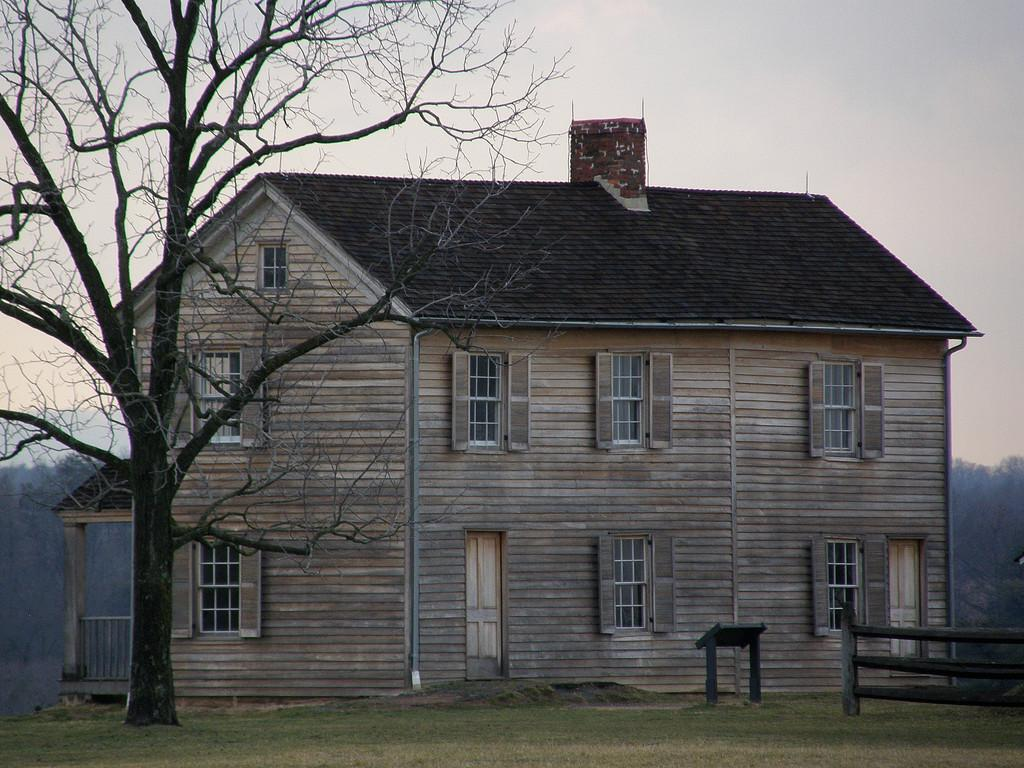What type of plant can be seen in the image? There is a tree in the image. What type of barrier is present in the image? There is a wooden fence in the image. What type of terrain is visible in the image? There is grassland in the image. What type of structure is present in the image? There is a wooden house in the image. What can be seen in the background of the image? The sky is visible in the background of the image. Which actor is performing on the grassland in the image? There is no actor or performance present in the image; it features a tree, wooden fence, grassland, wooden house, and sky. What type of spot is visible on the tree in the image? There is no spot visible on the tree in the image; it appears to be a healthy tree. 